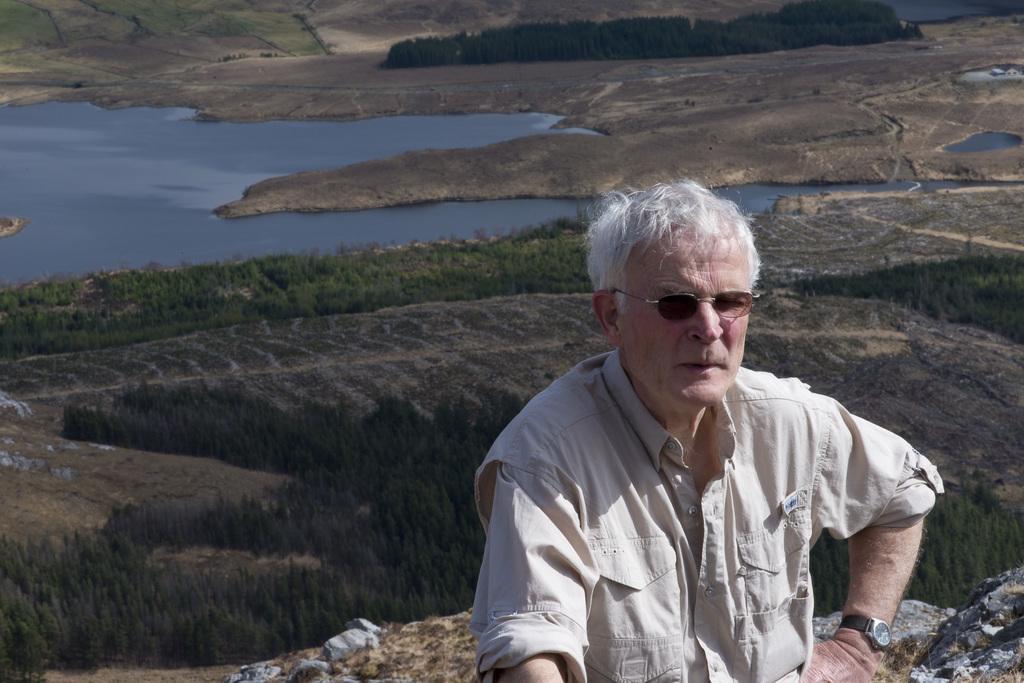Please provide a concise description of this image. In this image I can see on the right side there is a man, he is wearing a shirt, spectacles. At the back side it looks like a pond and there are trees. 